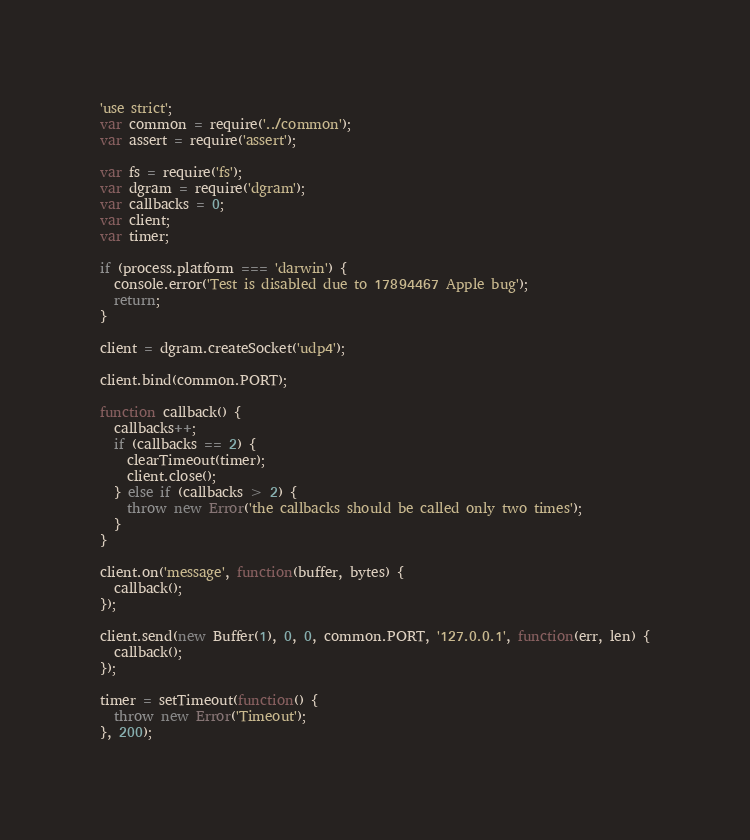<code> <loc_0><loc_0><loc_500><loc_500><_JavaScript_>'use strict';
var common = require('../common');
var assert = require('assert');

var fs = require('fs');
var dgram = require('dgram');
var callbacks = 0;
var client;
var timer;

if (process.platform === 'darwin') {
  console.error('Test is disabled due to 17894467 Apple bug');
  return;
}

client = dgram.createSocket('udp4');

client.bind(common.PORT);

function callback() {
  callbacks++;
  if (callbacks == 2) {
    clearTimeout(timer);
    client.close();
  } else if (callbacks > 2) {
    throw new Error('the callbacks should be called only two times');
  }
}

client.on('message', function(buffer, bytes) {
  callback();
});

client.send(new Buffer(1), 0, 0, common.PORT, '127.0.0.1', function(err, len) {
  callback();
});

timer = setTimeout(function() {
  throw new Error('Timeout');
}, 200);
</code> 